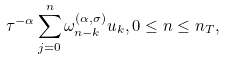<formula> <loc_0><loc_0><loc_500><loc_500>\tau ^ { - \alpha } \sum _ { j = 0 } ^ { n } \omega ^ { ( \alpha , \sigma ) } _ { n - k } u _ { k } , 0 \leq n \leq n _ { T } ,</formula> 